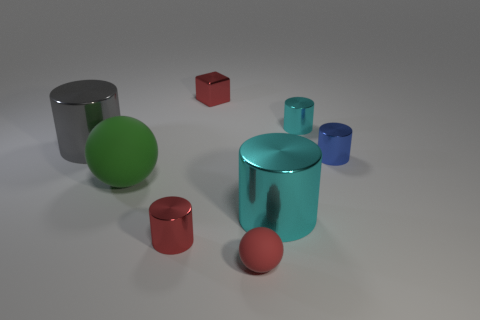What is the material texture of the objects displayed in the image? The objects in the image seem to have a smooth and reflective metallic texture, indicating they may be made of metal or a similar material giving them a polished appearance. Could you guess the time of day just by looking at this indoor setup? As the scene appears to be an indoor studio setup with controlled lighting, it's not possible to infer the time of day from the image alone. 